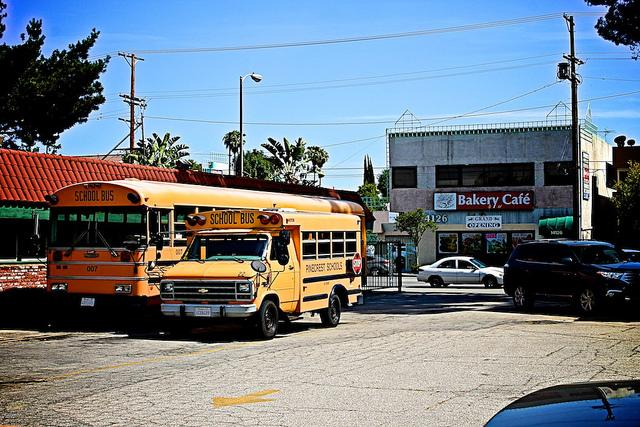When stopped what part of the smaller bus might most frequently pop out away from it's side?

Choices:
A) tires
B) tail pipe
C) hood
D) stop sign stop sign 